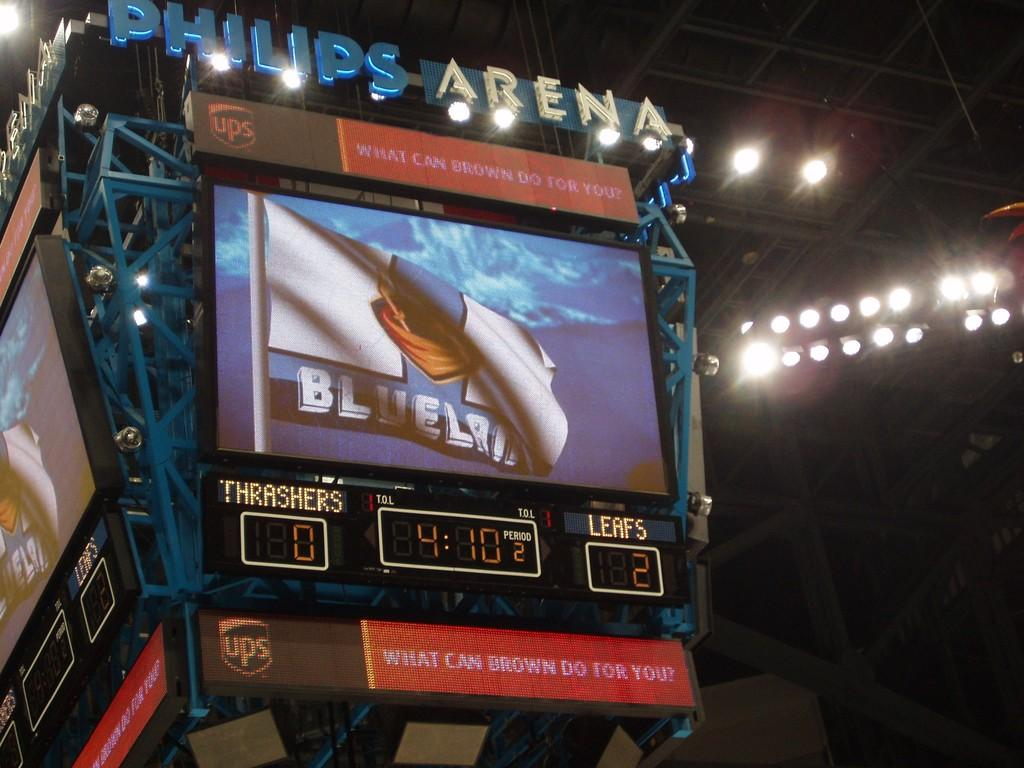Provide a one-sentence caption for the provided image. a Philips Arena sports display featuring a game between the Thrashers and Leafs. 